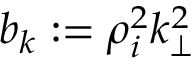Convert formula to latex. <formula><loc_0><loc_0><loc_500><loc_500>b _ { k } \colon = \rho _ { i } ^ { 2 } k _ { \perp } ^ { 2 }</formula> 